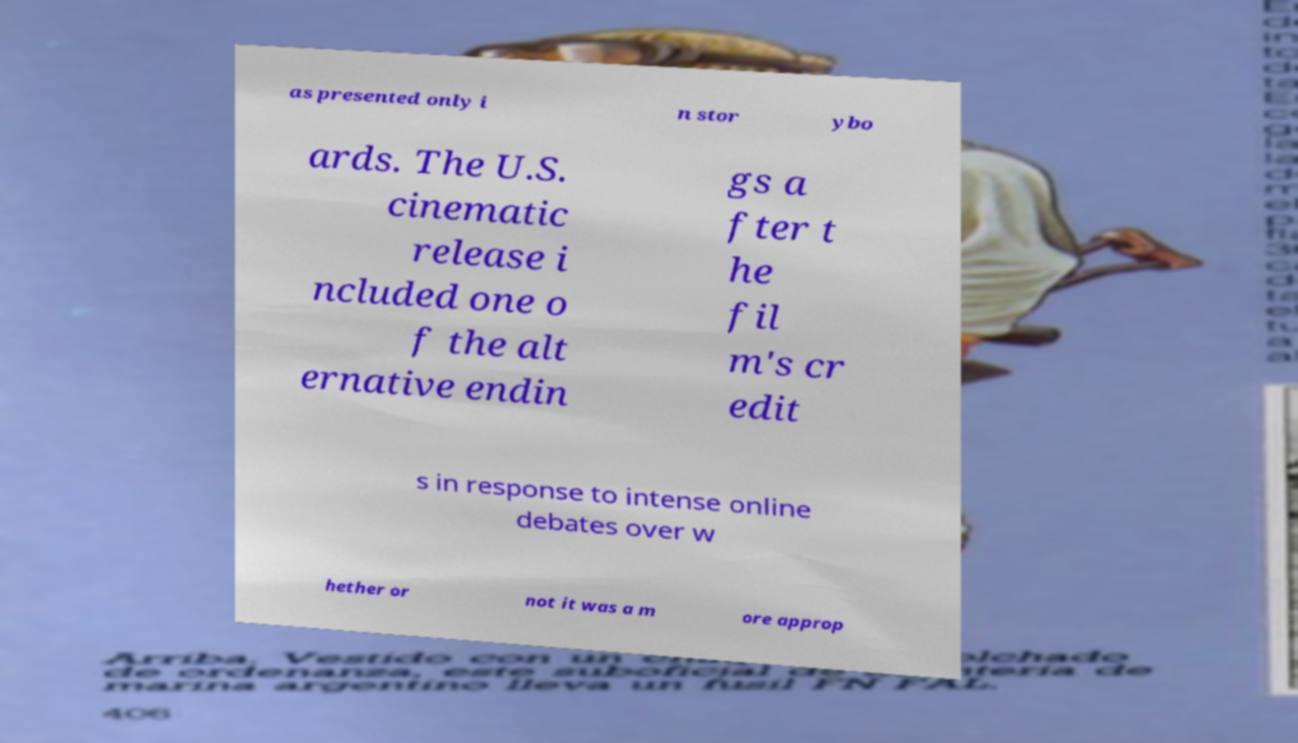There's text embedded in this image that I need extracted. Can you transcribe it verbatim? as presented only i n stor ybo ards. The U.S. cinematic release i ncluded one o f the alt ernative endin gs a fter t he fil m's cr edit s in response to intense online debates over w hether or not it was a m ore approp 